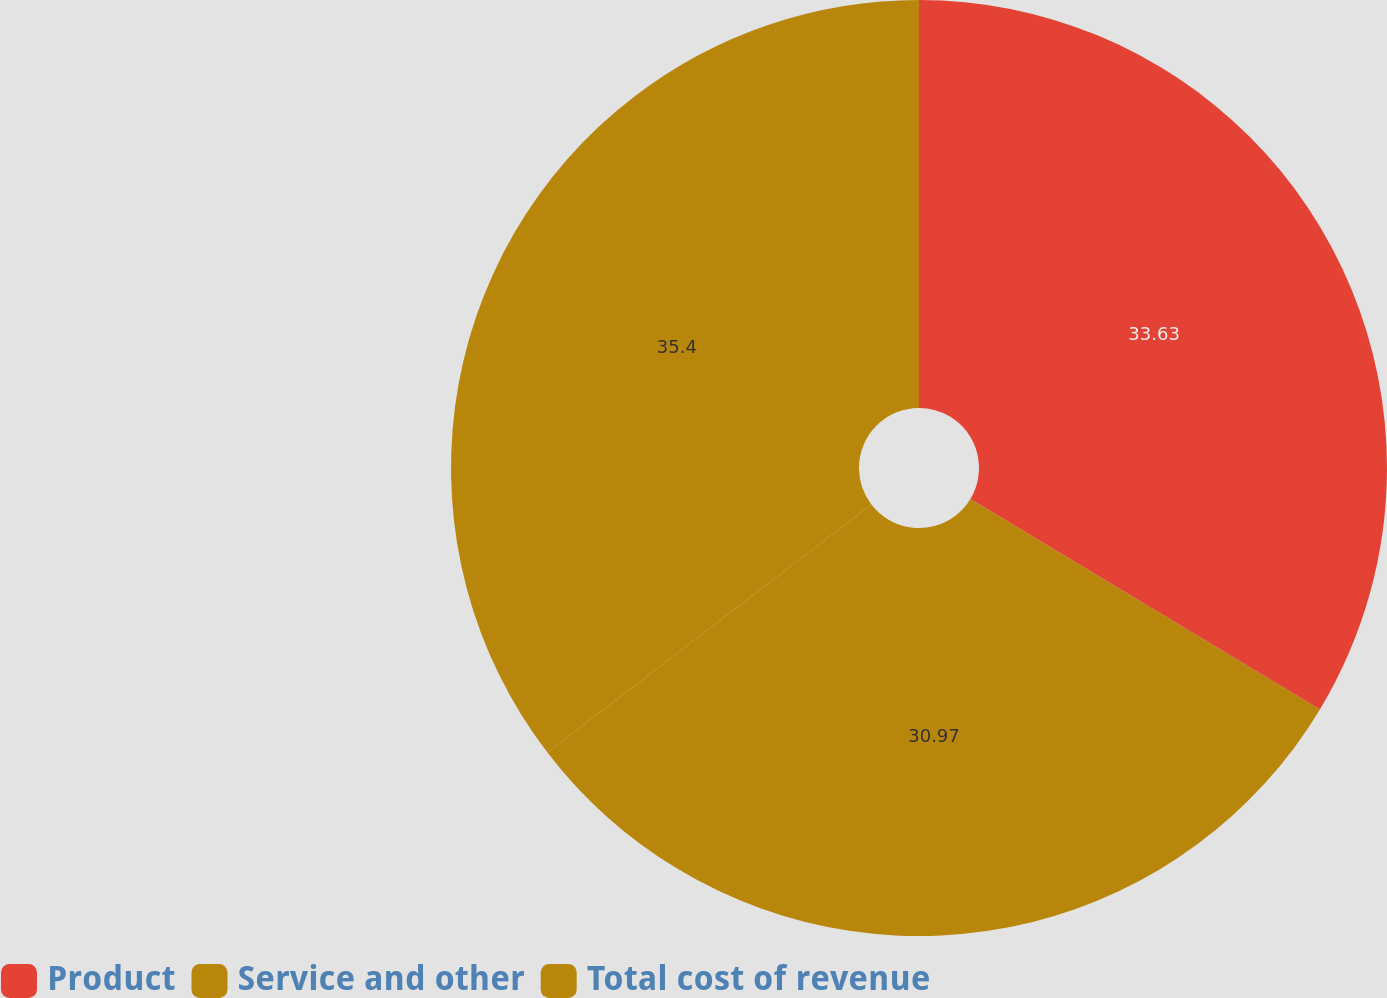Convert chart. <chart><loc_0><loc_0><loc_500><loc_500><pie_chart><fcel>Product<fcel>Service and other<fcel>Total cost of revenue<nl><fcel>33.63%<fcel>30.97%<fcel>35.4%<nl></chart> 